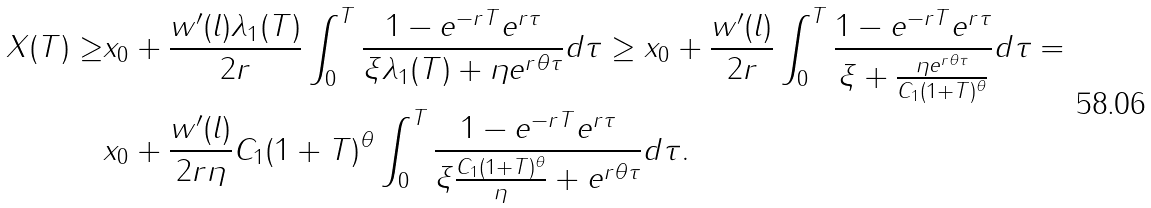<formula> <loc_0><loc_0><loc_500><loc_500>X ( T ) \geq & x _ { 0 } + \frac { w ^ { \prime } ( l ) \lambda _ { 1 } ( T ) } { 2 r } \int _ { 0 } ^ { T } \frac { 1 - e ^ { - r T } e ^ { r \tau } } { \xi \lambda _ { 1 } ( T ) + \eta e ^ { r \theta \tau } } d \tau \geq x _ { 0 } + \frac { w ^ { \prime } ( l ) } { 2 r } \int _ { 0 } ^ { T } \frac { 1 - e ^ { - r T } e ^ { r \tau } } { \xi + \frac { \eta e ^ { r \theta \tau } } { C _ { 1 } ( 1 + T ) ^ { \theta } } } d \tau = \\ & x _ { 0 } + \frac { w ^ { \prime } ( l ) } { 2 r \eta } C _ { 1 } ( 1 + T ) ^ { \theta } \int _ { 0 } ^ { T } \frac { 1 - e ^ { - r T } e ^ { r \tau } } { \xi \frac { C _ { 1 } ( 1 + T ) ^ { \theta } } { \eta } + e ^ { r \theta \tau } } d \tau .</formula> 